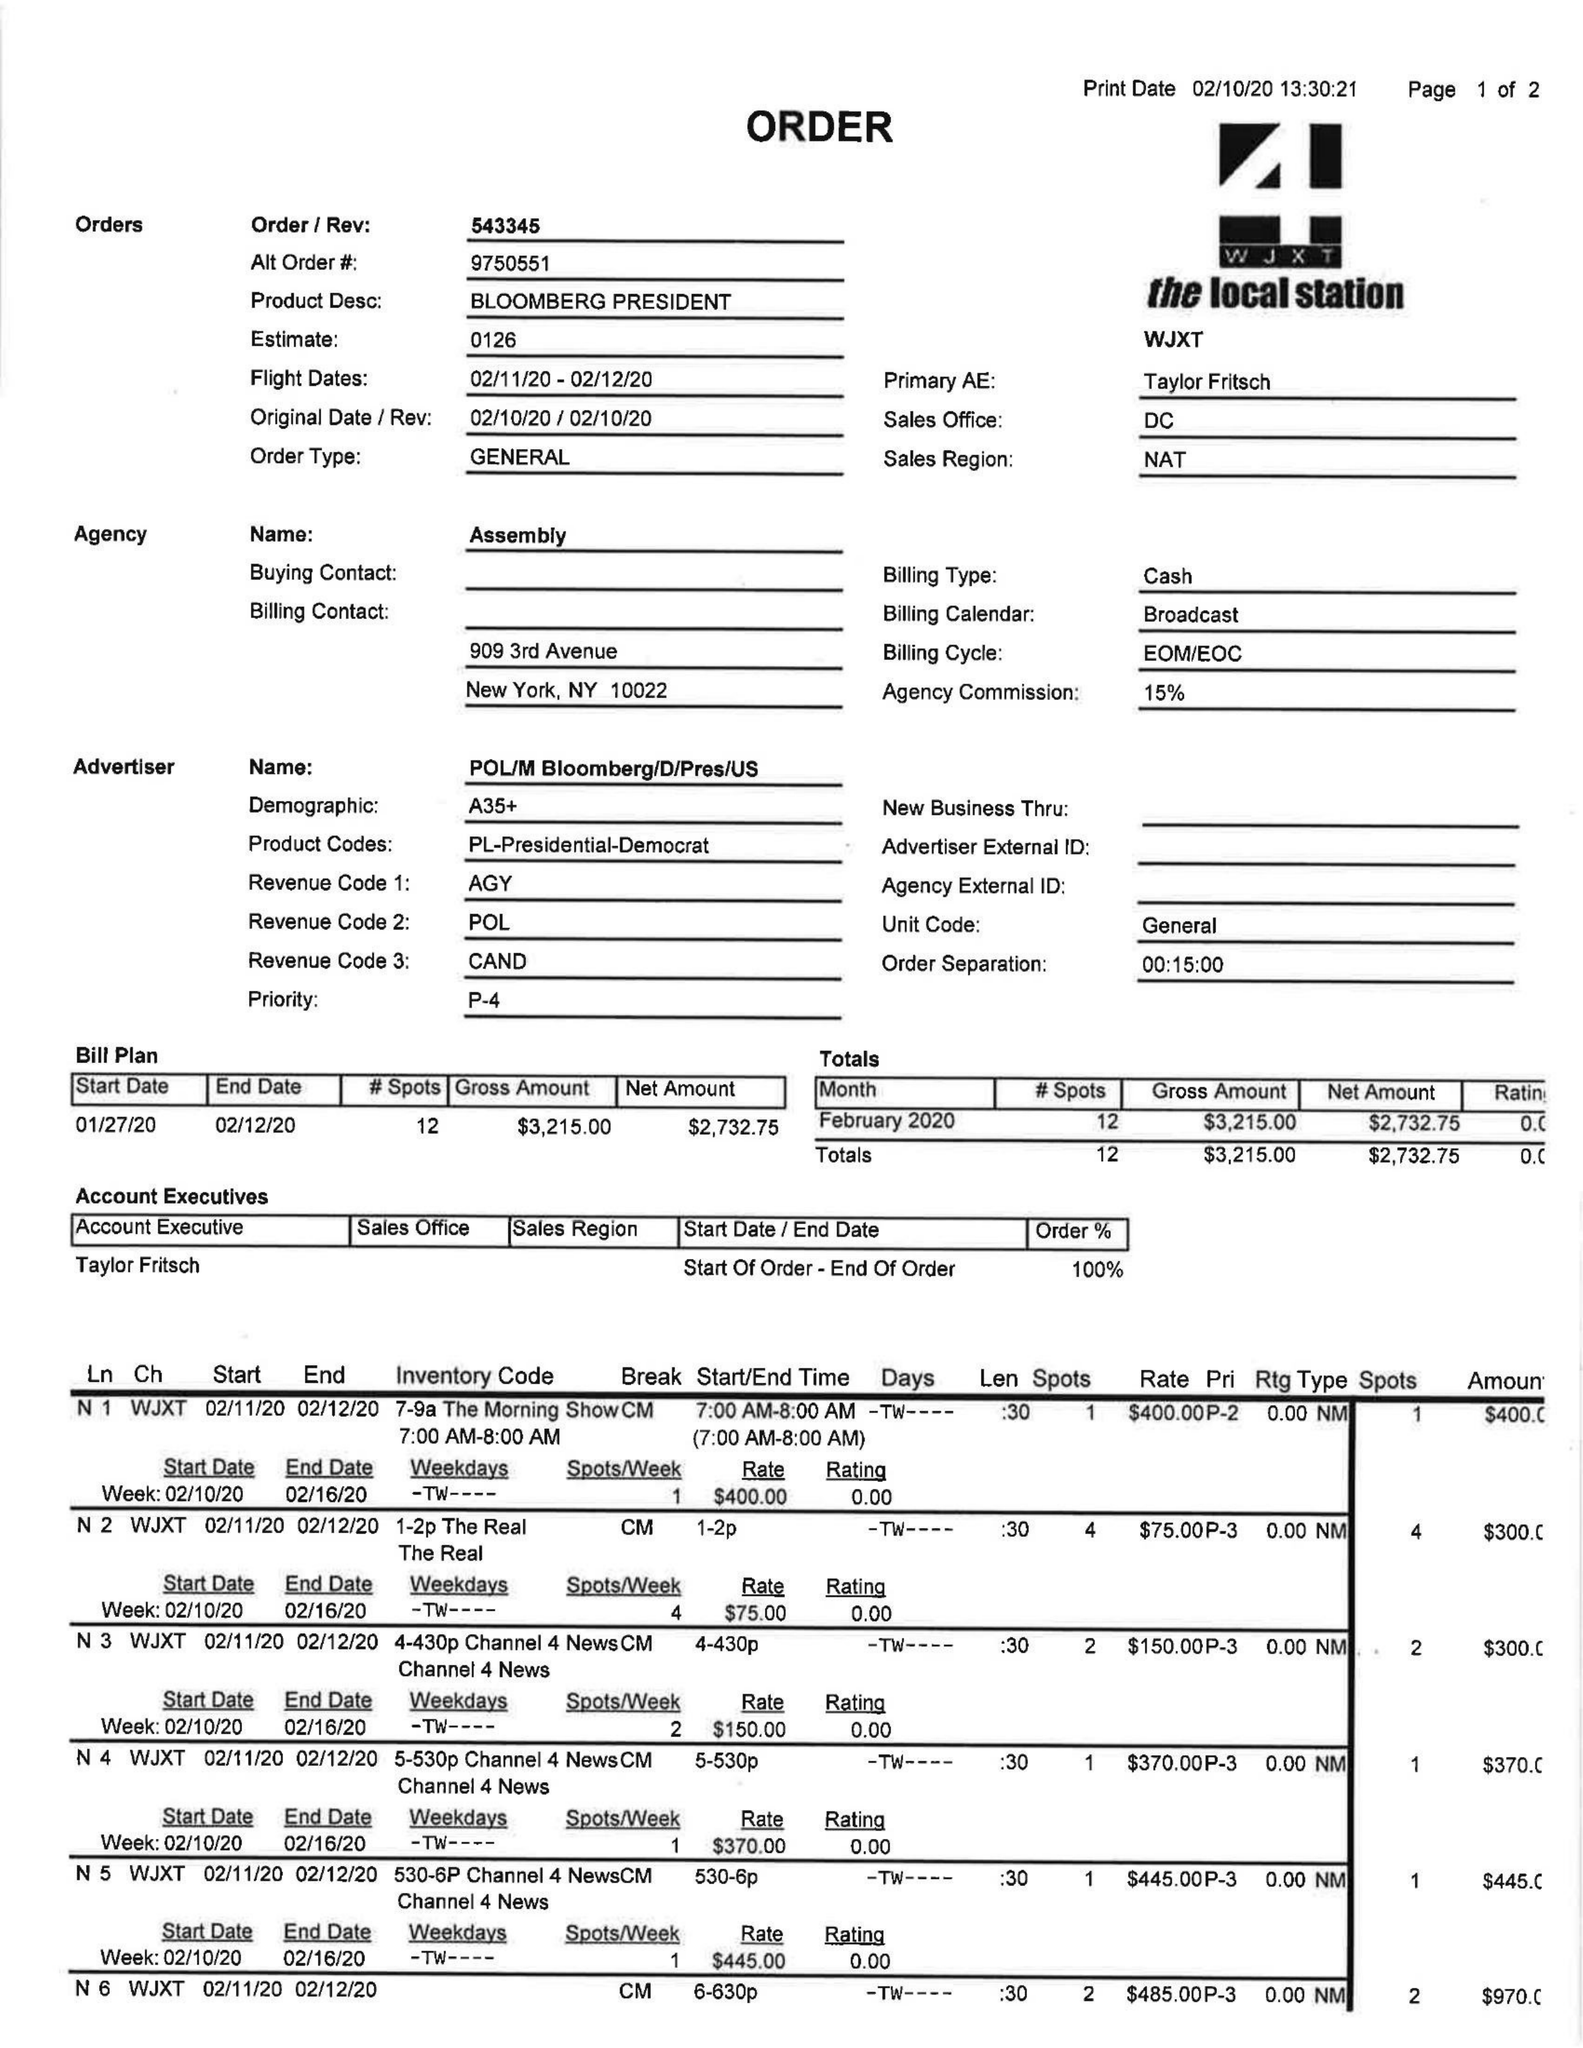What is the value for the gross_amount?
Answer the question using a single word or phrase. 3215.00 